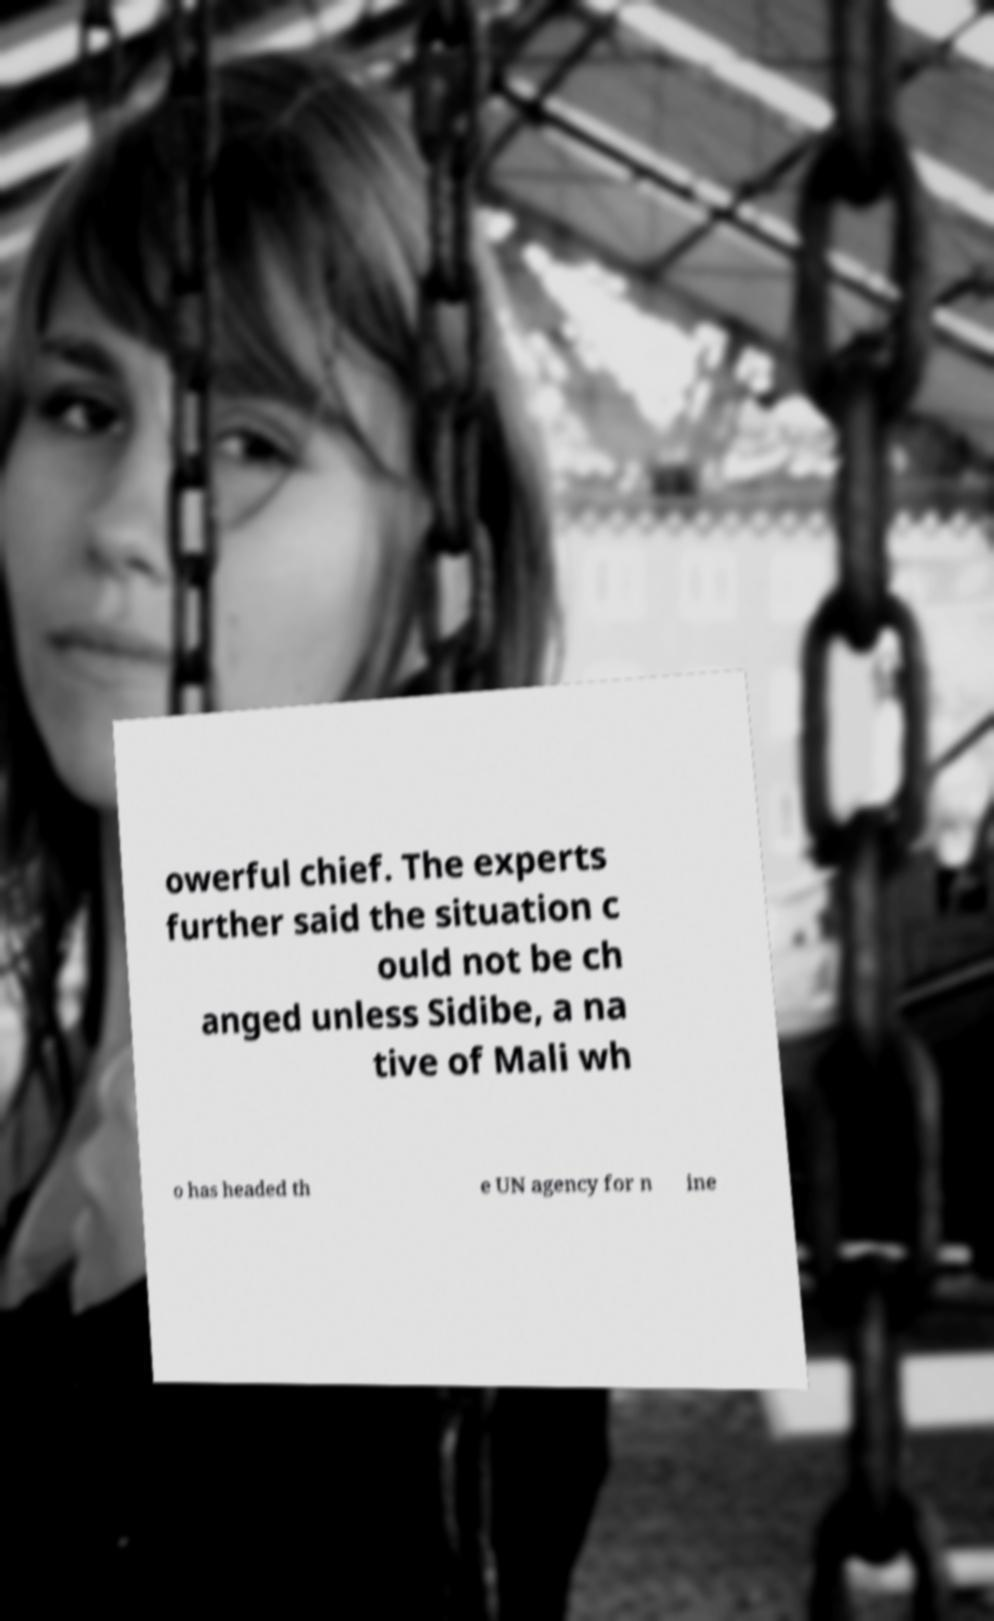For documentation purposes, I need the text within this image transcribed. Could you provide that? owerful chief. The experts further said the situation c ould not be ch anged unless Sidibe, a na tive of Mali wh o has headed th e UN agency for n ine 